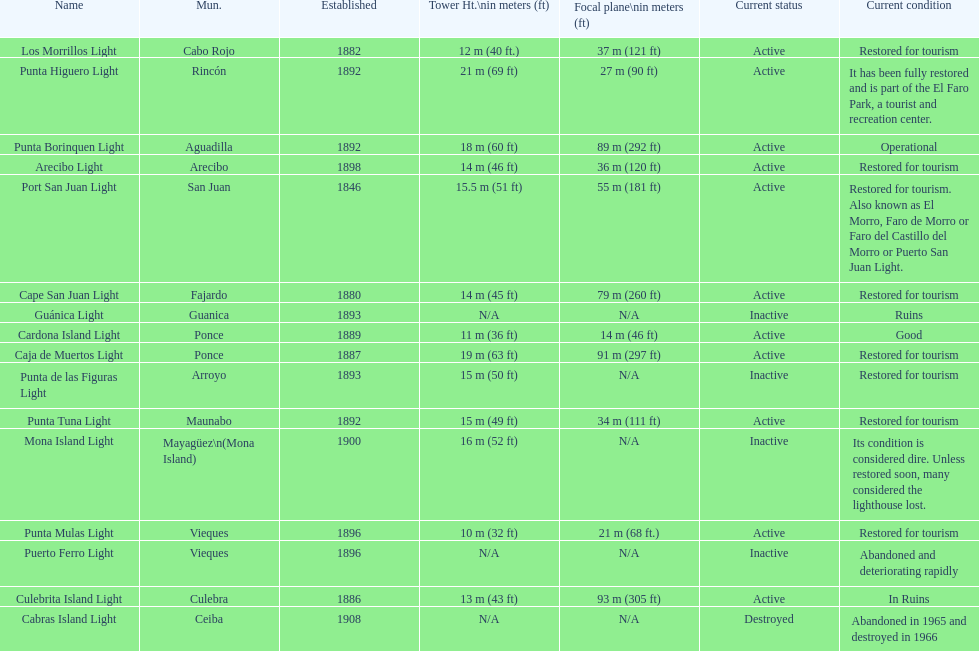Cardona island light and caja de muertos light are both located in what municipality? Ponce. 